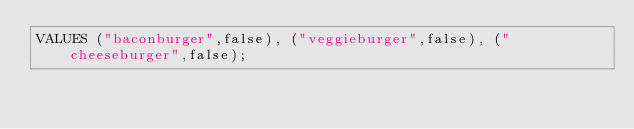Convert code to text. <code><loc_0><loc_0><loc_500><loc_500><_SQL_>VALUES ("baconburger",false), ("veggieburger",false), ("cheeseburger",false);
</code> 